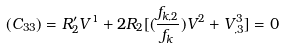Convert formula to latex. <formula><loc_0><loc_0><loc_500><loc_500>( C _ { 3 3 } ) = R ^ { \prime } _ { 2 } V ^ { 1 } + 2 R _ { 2 } [ ( \frac { f _ { k , 2 } } { f _ { k } } ) V ^ { 2 } + V ^ { 3 } _ { , 3 } ] = 0</formula> 